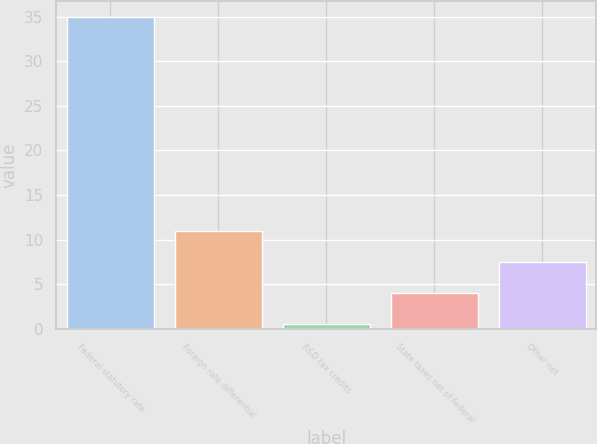Convert chart to OTSL. <chart><loc_0><loc_0><loc_500><loc_500><bar_chart><fcel>Federal statutory rate<fcel>Foreign rate differential<fcel>R&D tax credits<fcel>State taxes net of federal<fcel>Other net<nl><fcel>35<fcel>10.92<fcel>0.6<fcel>4.04<fcel>7.48<nl></chart> 